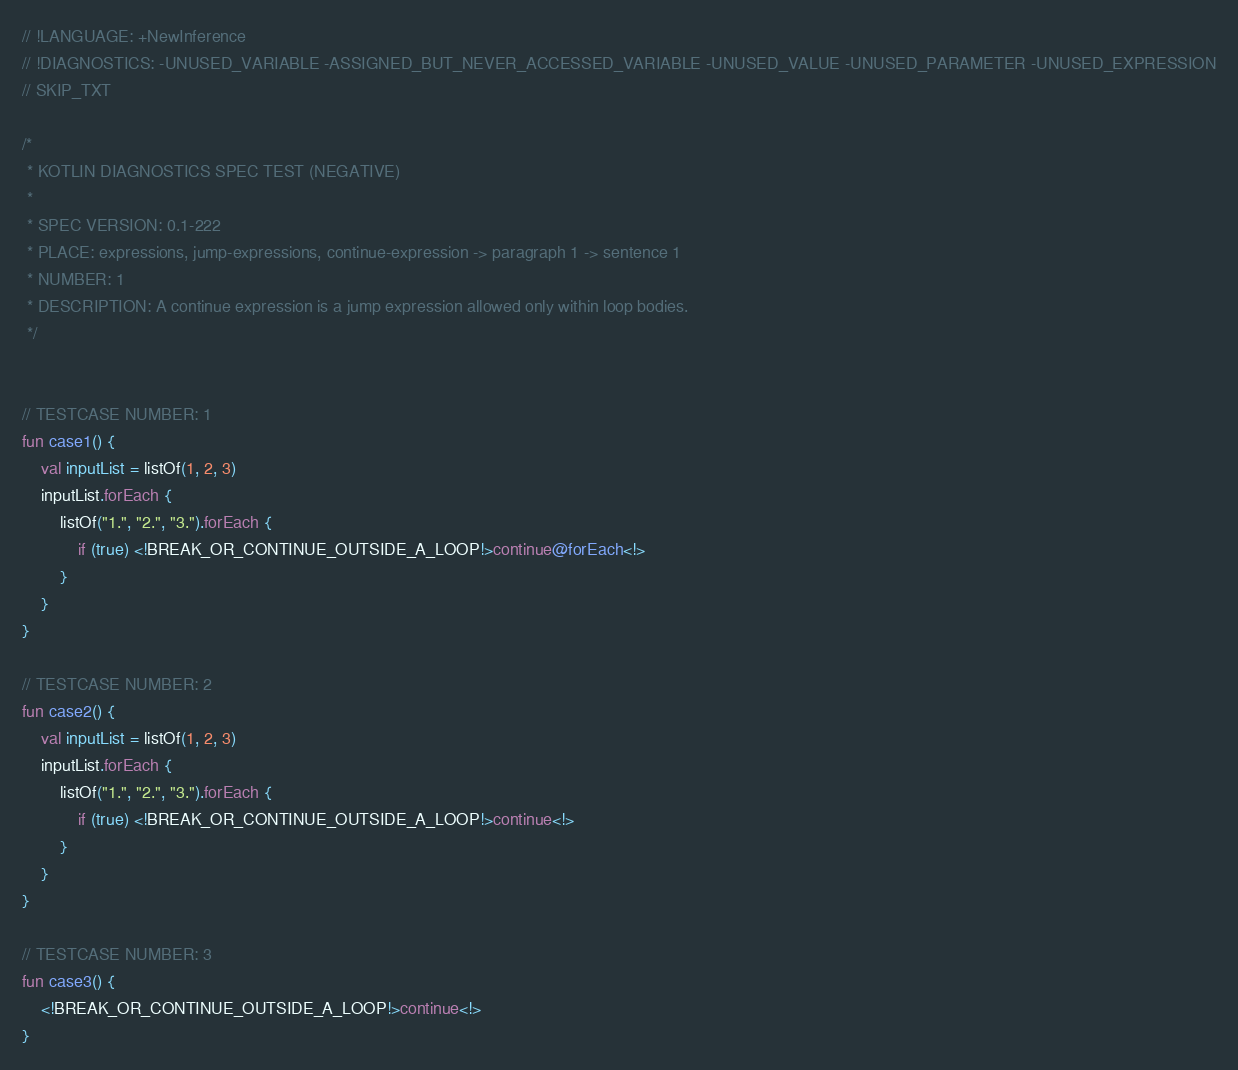<code> <loc_0><loc_0><loc_500><loc_500><_Kotlin_>// !LANGUAGE: +NewInference
// !DIAGNOSTICS: -UNUSED_VARIABLE -ASSIGNED_BUT_NEVER_ACCESSED_VARIABLE -UNUSED_VALUE -UNUSED_PARAMETER -UNUSED_EXPRESSION
// SKIP_TXT

/*
 * KOTLIN DIAGNOSTICS SPEC TEST (NEGATIVE)
 *
 * SPEC VERSION: 0.1-222
 * PLACE: expressions, jump-expressions, continue-expression -> paragraph 1 -> sentence 1
 * NUMBER: 1
 * DESCRIPTION: A continue expression is a jump expression allowed only within loop bodies.
 */


// TESTCASE NUMBER: 1
fun case1() {
    val inputList = listOf(1, 2, 3)
    inputList.forEach {
        listOf("1.", "2.", "3.").forEach {
            if (true) <!BREAK_OR_CONTINUE_OUTSIDE_A_LOOP!>continue@forEach<!>
        }
    }
}

// TESTCASE NUMBER: 2
fun case2() {
    val inputList = listOf(1, 2, 3)
    inputList.forEach {
        listOf("1.", "2.", "3.").forEach {
            if (true) <!BREAK_OR_CONTINUE_OUTSIDE_A_LOOP!>continue<!>
        }
    }
}

// TESTCASE NUMBER: 3
fun case3() {
    <!BREAK_OR_CONTINUE_OUTSIDE_A_LOOP!>continue<!>
}
</code> 